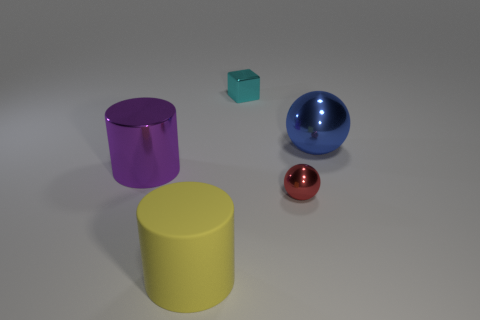Is there anything else that has the same material as the large yellow thing?
Ensure brevity in your answer.  No. Are there any other spheres made of the same material as the blue sphere?
Your answer should be very brief. Yes. There is a metallic ball behind the cylinder that is to the left of the yellow object; are there any blue objects left of it?
Ensure brevity in your answer.  No. What number of other objects are there of the same shape as the cyan thing?
Provide a short and direct response. 0. There is a small thing right of the tiny thing left of the red shiny thing that is in front of the cyan metallic object; what color is it?
Offer a very short reply. Red. How many large cyan cylinders are there?
Your response must be concise. 0. What number of tiny objects are either green spheres or purple metallic cylinders?
Keep it short and to the point. 0. There is another thing that is the same size as the cyan object; what shape is it?
Ensure brevity in your answer.  Sphere. What material is the large object in front of the small object to the right of the cyan shiny thing?
Provide a succinct answer. Rubber. Is the yellow rubber cylinder the same size as the blue sphere?
Your response must be concise. Yes. 